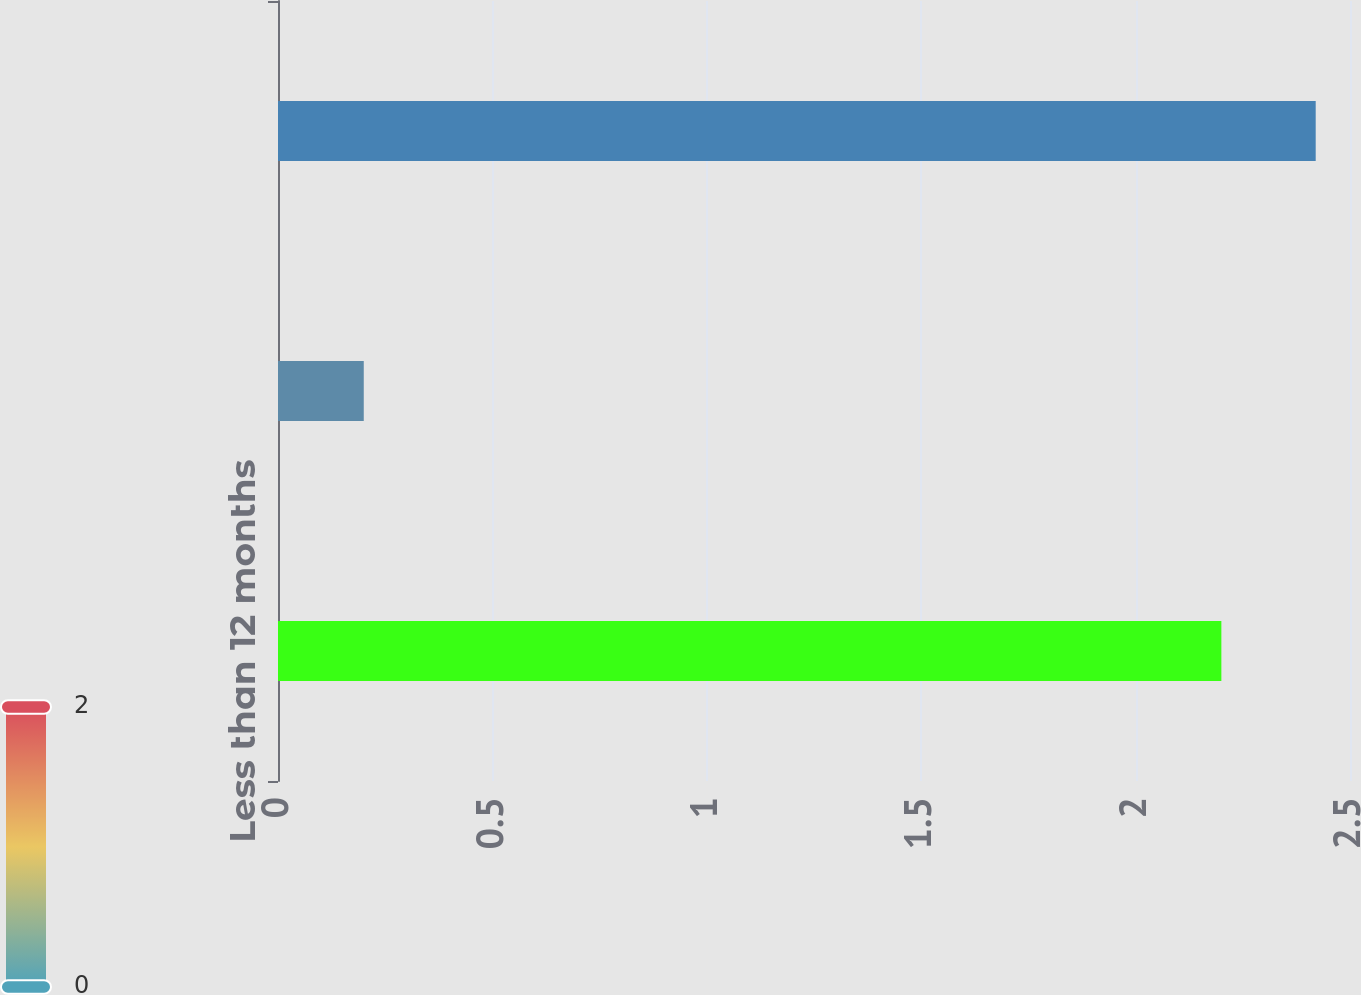Convert chart to OTSL. <chart><loc_0><loc_0><loc_500><loc_500><bar_chart><fcel>Less than 12 months<fcel>More than 12 months<fcel>Total<nl><fcel>2.2<fcel>0.2<fcel>2.42<nl></chart> 